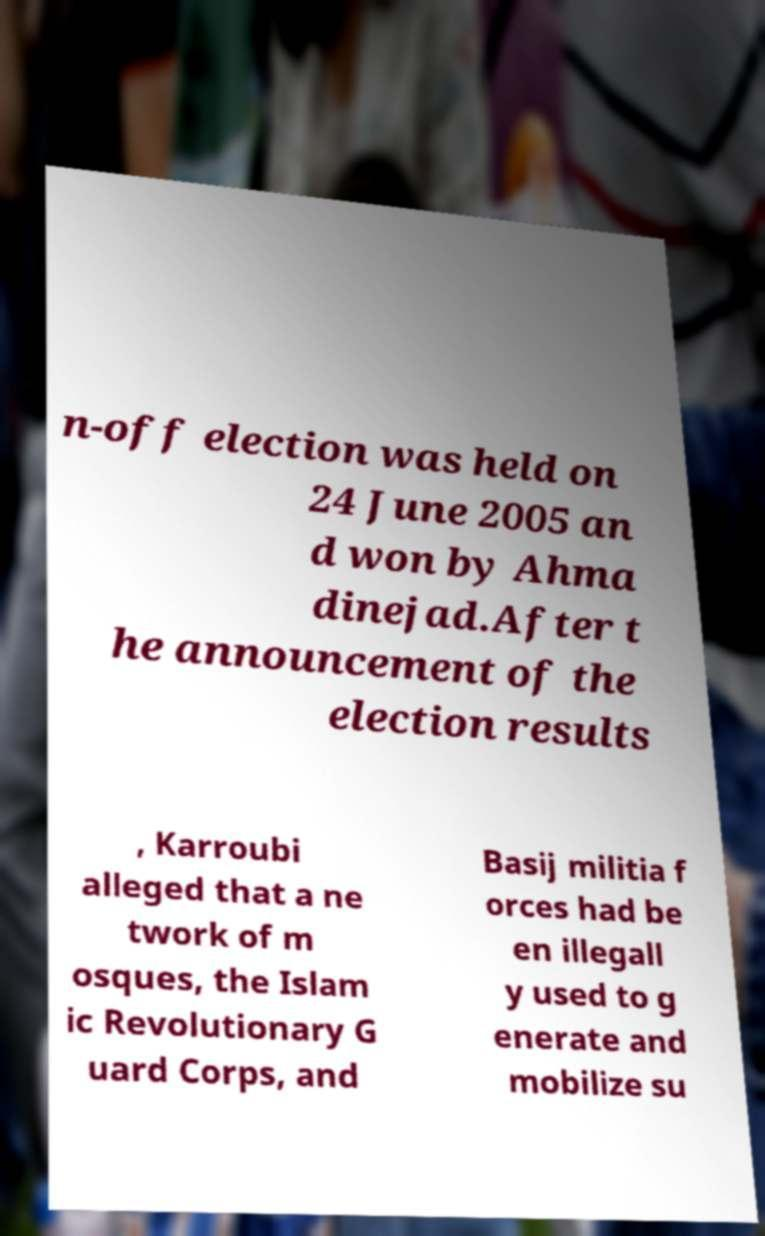Please read and relay the text visible in this image. What does it say? n-off election was held on 24 June 2005 an d won by Ahma dinejad.After t he announcement of the election results , Karroubi alleged that a ne twork of m osques, the Islam ic Revolutionary G uard Corps, and Basij militia f orces had be en illegall y used to g enerate and mobilize su 